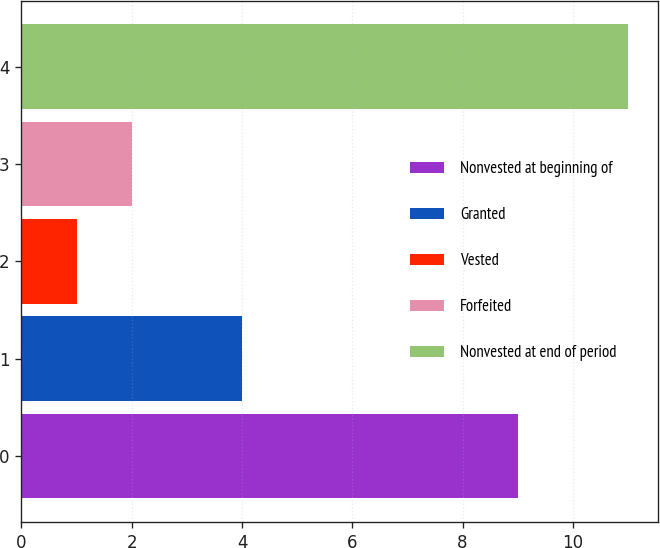<chart> <loc_0><loc_0><loc_500><loc_500><bar_chart><fcel>Nonvested at beginning of<fcel>Granted<fcel>Vested<fcel>Forfeited<fcel>Nonvested at end of period<nl><fcel>9<fcel>4<fcel>1<fcel>2<fcel>11<nl></chart> 